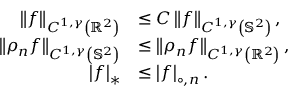Convert formula to latex. <formula><loc_0><loc_0><loc_500><loc_500>\begin{array} { r l } { \left \| f \right \| _ { C ^ { 1 , \gamma } \left ( { \mathbb { R } ^ { 2 } } \right ) } } & { \leq C \left \| f \right \| _ { C ^ { 1 , \gamma } \left ( { \mathbb { S } ^ { 2 } } \right ) } , } \\ { \left \| \rho _ { n } f \right \| _ { C ^ { 1 , \gamma } \left ( { \mathbb { S } ^ { 2 } } \right ) } } & { \leq \left \| \rho _ { n } f \right \| _ { C ^ { 1 , \gamma } \left ( { \mathbb { R } ^ { 2 } } \right ) } , } \\ { \left | f \right | _ { * } } & { \leq \left | f \right | _ { \circ , n } . } \end{array}</formula> 